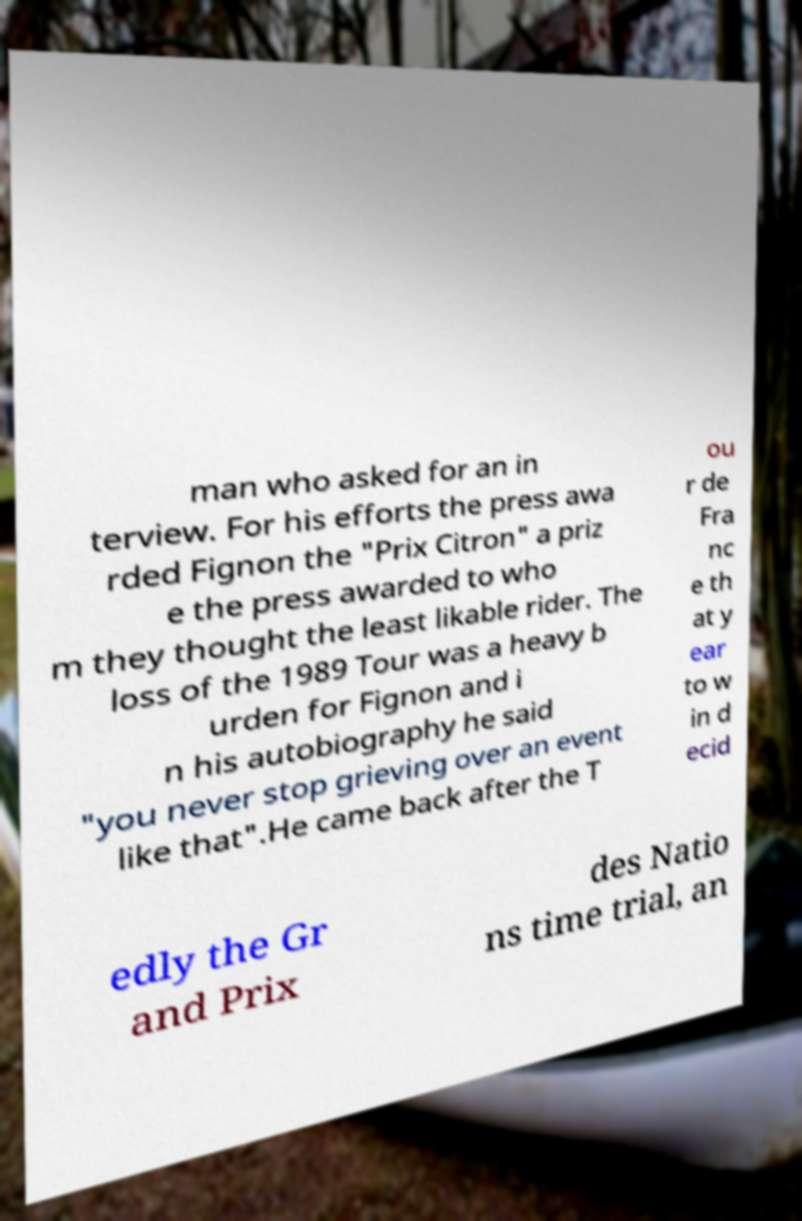Could you assist in decoding the text presented in this image and type it out clearly? man who asked for an in terview. For his efforts the press awa rded Fignon the "Prix Citron" a priz e the press awarded to who m they thought the least likable rider. The loss of the 1989 Tour was a heavy b urden for Fignon and i n his autobiography he said "you never stop grieving over an event like that".He came back after the T ou r de Fra nc e th at y ear to w in d ecid edly the Gr and Prix des Natio ns time trial, an 